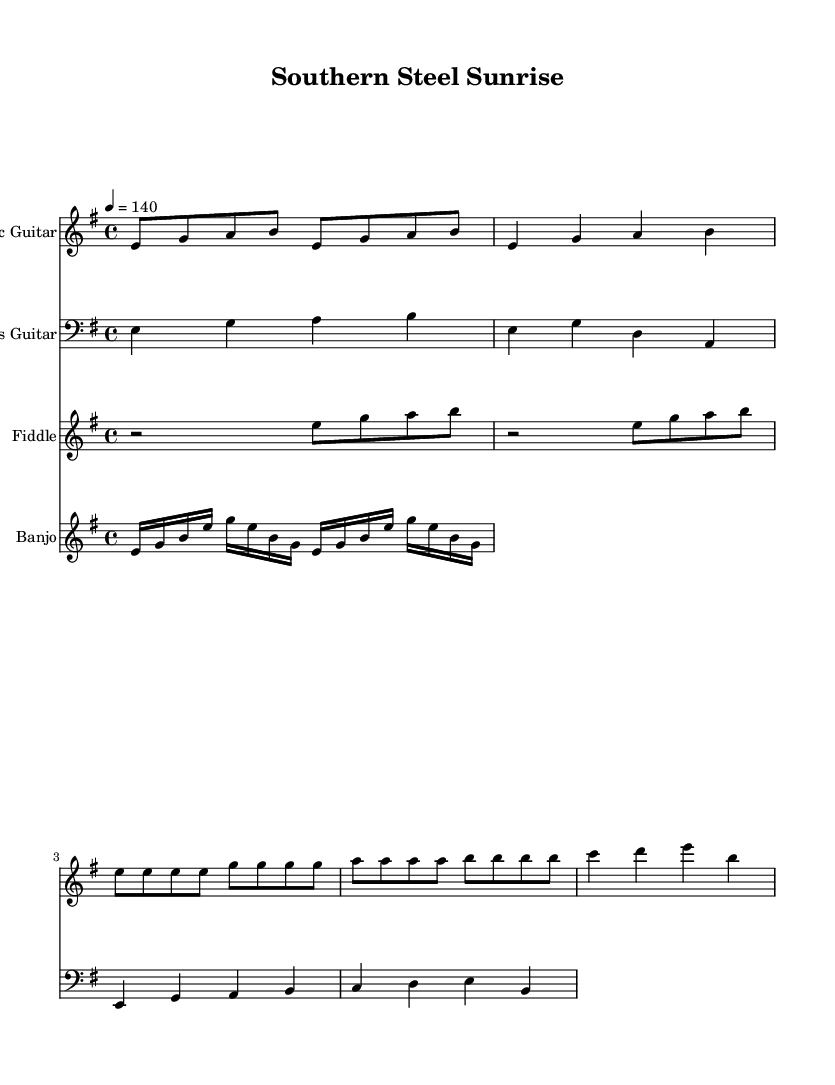What is the key signature of this music? The key signature is E minor, which has one sharp (F#). Within the global music variables, the key signature is defined using the command "\key e \minor," indicating that the piece is in E minor.
Answer: E minor What is the time signature of this music? The time signature is 4/4, which can be found in the global section where it states "\time 4/4." This indicates that there are four beats in each measure and the quarter note gets one beat.
Answer: 4/4 What is the tempo marking for this piece? The tempo marking is quarter note equals 140 beats per minute. This is specified in the global section as "\tempo 4 = 140," indicating the speed at which the music should be played.
Answer: 140 How many measures are included in the electric guitar part? The electric guitar part has a total of 6 measures. By counting the measures notated in the electricGuitar section, the measures contain introductory and verse patterns plus the chorus and bridge. Thus, the tally includes all distinct groupings of notes and rests.
Answer: 6 What instrument plays arpeggiated patterns? The banjo plays the arpeggiated patterns as indicated in the banjo staff. The code shows a repeating arpeggiated figure, affirming the banjo's role in providing this characteristic texture in the music.
Answer: Banjo Which section contains the chorus? The chorus is found after the verse section in the electric guitar part, indicated by the specific repeated notes and the pattern which aligns with common song structures that typically have a clear identifiable chorus.
Answer: Following verse What is the primary musical style of this piece? The primary musical style is Southern-influenced metal, which can be inferred from the combination of metal instrumentation like electric guitar and bass, along with traditional elements such as fiddle and banjo that incorporate country characteristics.
Answer: Southern-influenced metal 